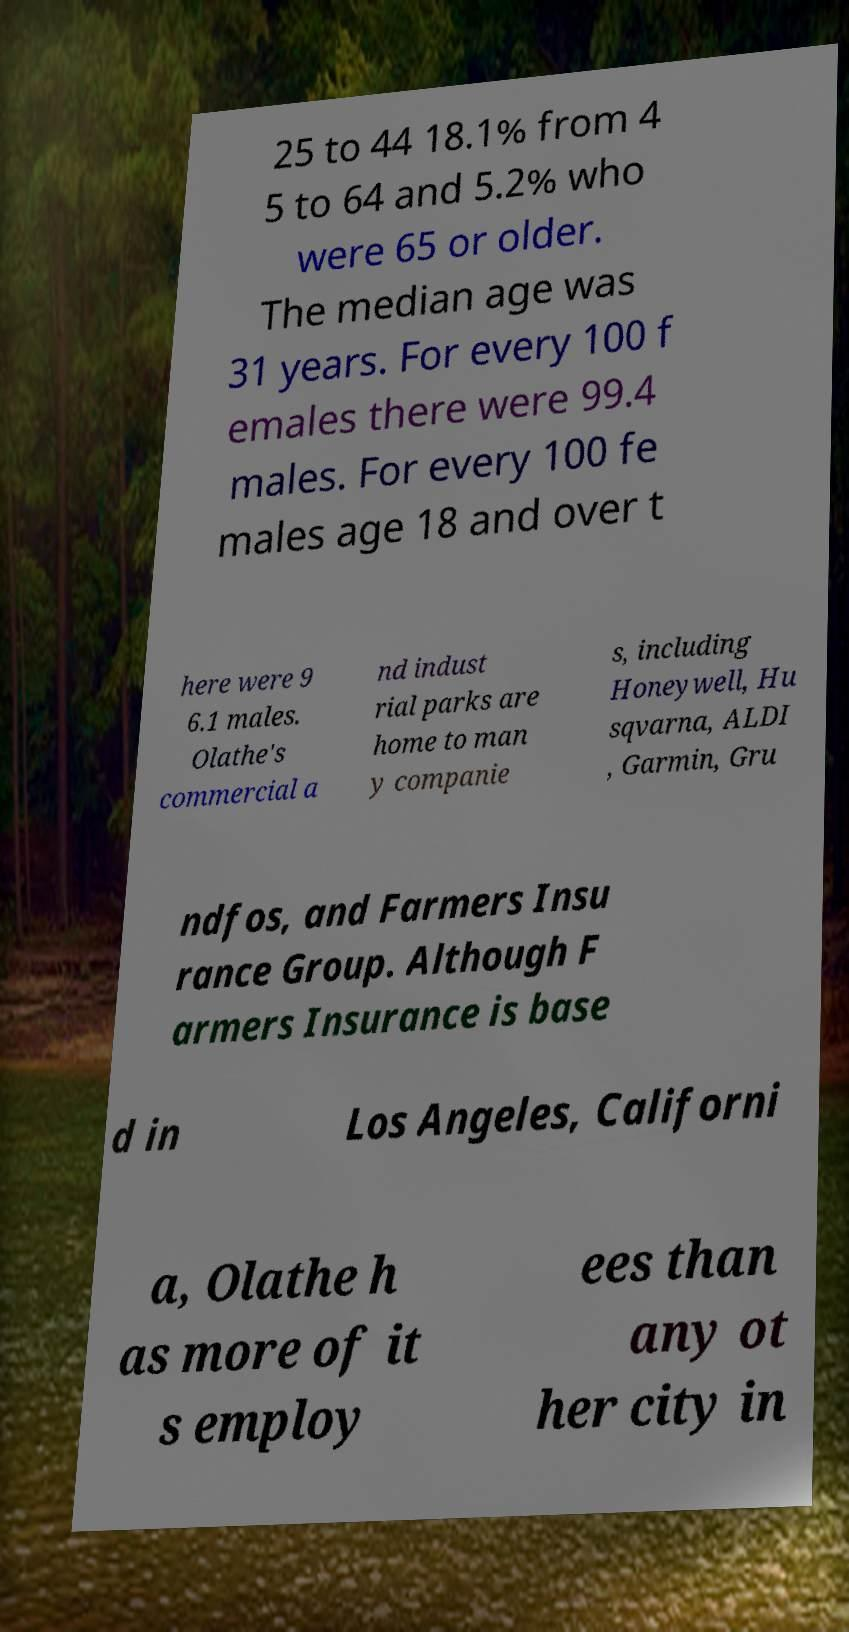Can you read and provide the text displayed in the image?This photo seems to have some interesting text. Can you extract and type it out for me? 25 to 44 18.1% from 4 5 to 64 and 5.2% who were 65 or older. The median age was 31 years. For every 100 f emales there were 99.4 males. For every 100 fe males age 18 and over t here were 9 6.1 males. Olathe's commercial a nd indust rial parks are home to man y companie s, including Honeywell, Hu sqvarna, ALDI , Garmin, Gru ndfos, and Farmers Insu rance Group. Although F armers Insurance is base d in Los Angeles, Californi a, Olathe h as more of it s employ ees than any ot her city in 